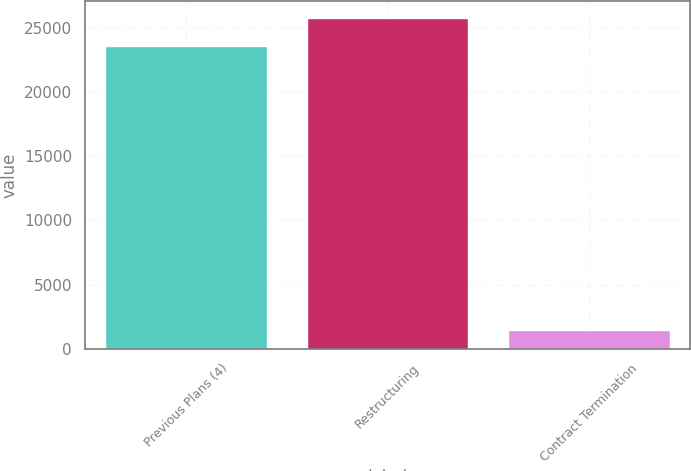<chart> <loc_0><loc_0><loc_500><loc_500><bar_chart><fcel>Previous Plans (4)<fcel>Restructuring<fcel>Contract Termination<nl><fcel>23581<fcel>25792.1<fcel>1470<nl></chart> 